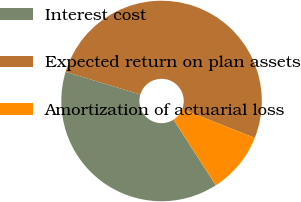Convert chart. <chart><loc_0><loc_0><loc_500><loc_500><pie_chart><fcel>Interest cost<fcel>Expected return on plan assets<fcel>Amortization of actuarial loss<nl><fcel>38.78%<fcel>51.32%<fcel>9.9%<nl></chart> 